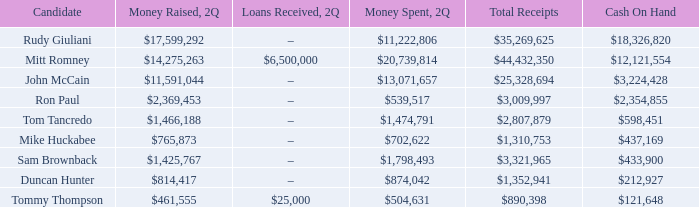Can you provide the sum of all receipts for tom tancredo? $2,807,879. 